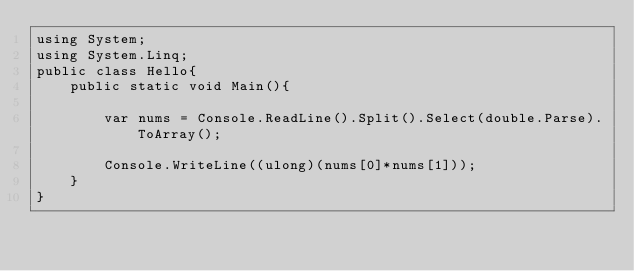<code> <loc_0><loc_0><loc_500><loc_500><_C#_>using System;
using System.Linq;
public class Hello{
    public static void Main(){
        
        var nums = Console.ReadLine().Split().Select(double.Parse).ToArray();
        
        Console.WriteLine((ulong)(nums[0]*nums[1]));
    }
}
</code> 